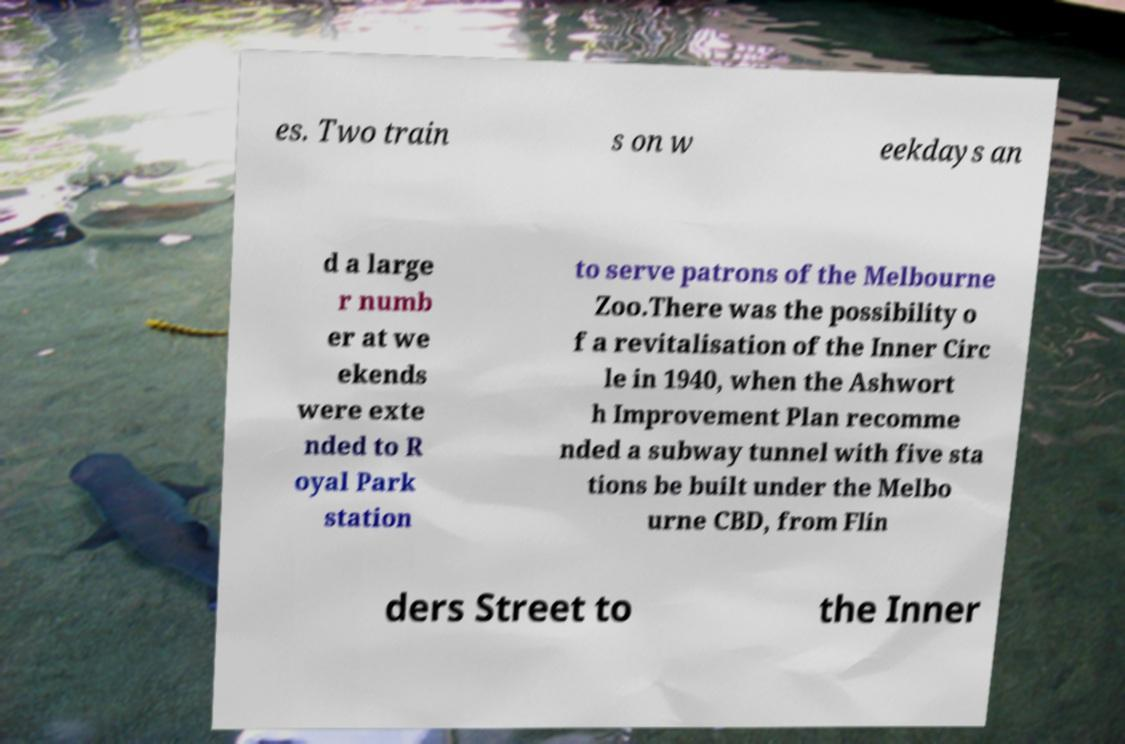What messages or text are displayed in this image? I need them in a readable, typed format. es. Two train s on w eekdays an d a large r numb er at we ekends were exte nded to R oyal Park station to serve patrons of the Melbourne Zoo.There was the possibility o f a revitalisation of the Inner Circ le in 1940, when the Ashwort h Improvement Plan recomme nded a subway tunnel with five sta tions be built under the Melbo urne CBD, from Flin ders Street to the Inner 